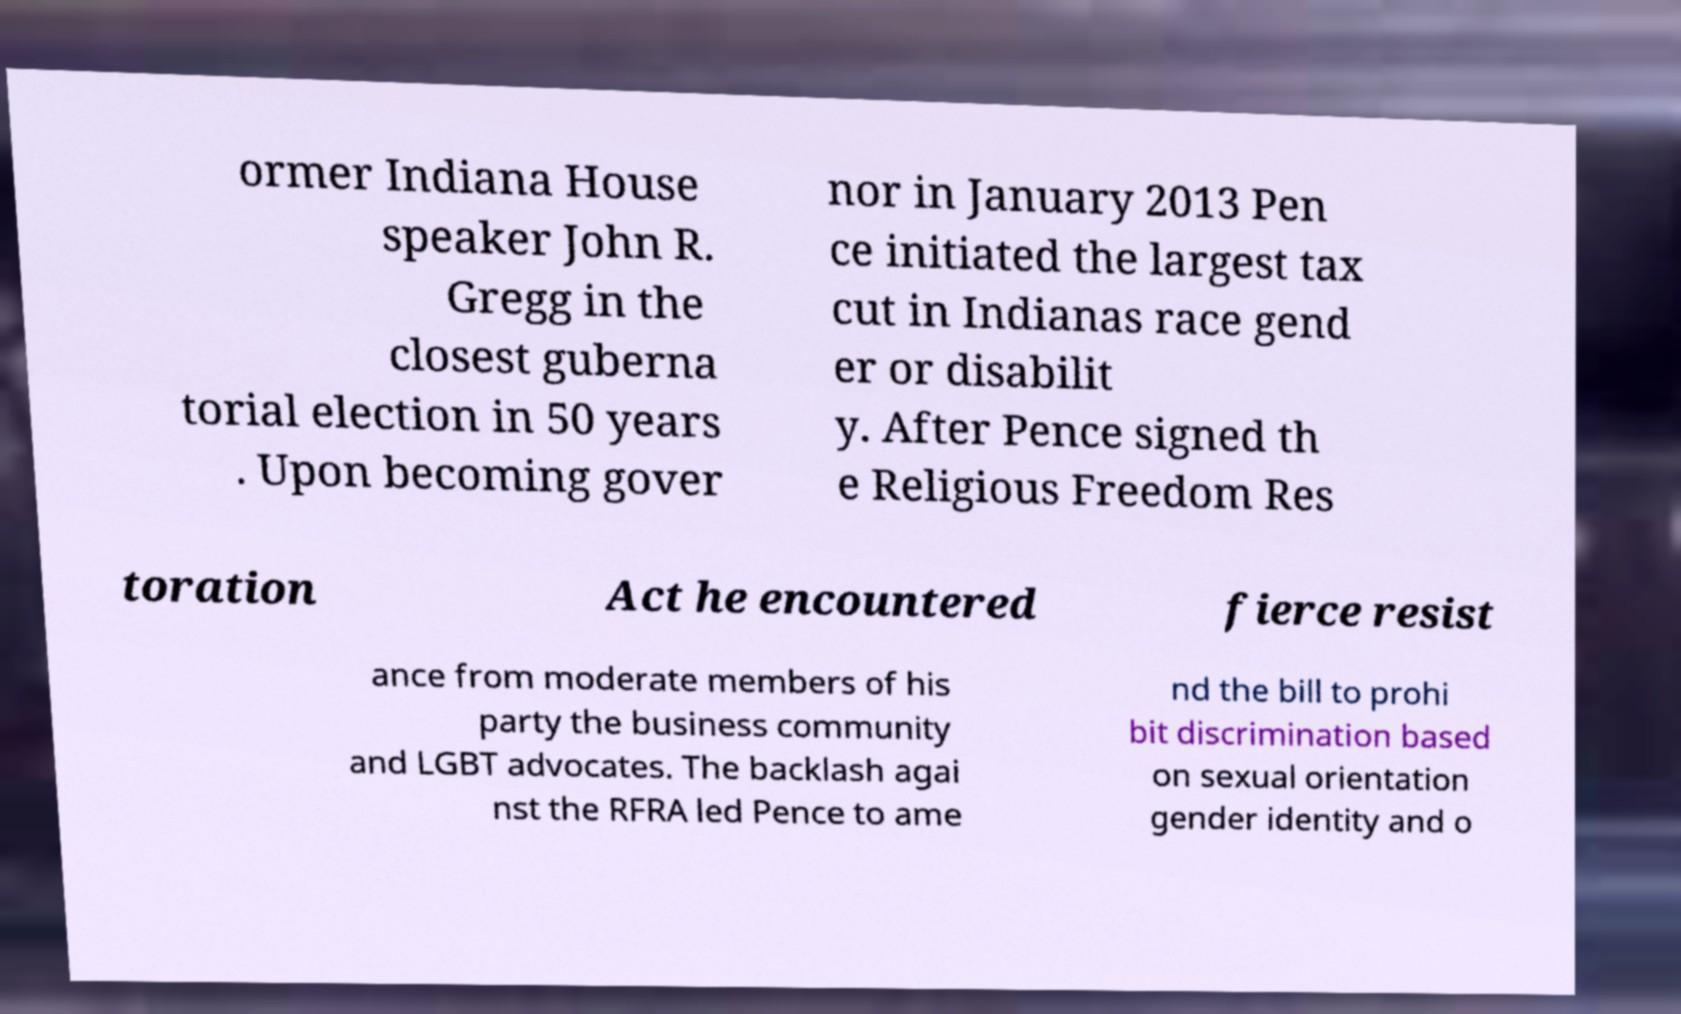For documentation purposes, I need the text within this image transcribed. Could you provide that? ormer Indiana House speaker John R. Gregg in the closest guberna torial election in 50 years . Upon becoming gover nor in January 2013 Pen ce initiated the largest tax cut in Indianas race gend er or disabilit y. After Pence signed th e Religious Freedom Res toration Act he encountered fierce resist ance from moderate members of his party the business community and LGBT advocates. The backlash agai nst the RFRA led Pence to ame nd the bill to prohi bit discrimination based on sexual orientation gender identity and o 